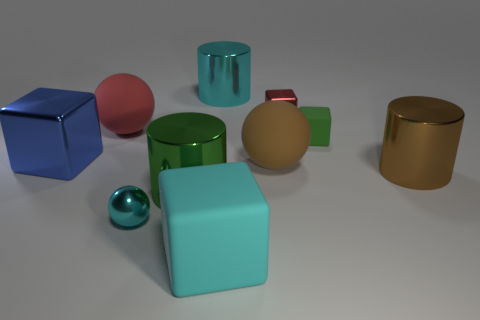Subtract all tiny metallic blocks. How many blocks are left? 3 Subtract all brown cylinders. How many cylinders are left? 2 Subtract 2 cylinders. How many cylinders are left? 1 Subtract all blue spheres. Subtract all green blocks. How many spheres are left? 3 Subtract all gray balls. How many green cylinders are left? 1 Subtract all yellow rubber cylinders. Subtract all cyan metallic objects. How many objects are left? 8 Add 8 blue objects. How many blue objects are left? 9 Add 8 big green rubber blocks. How many big green rubber blocks exist? 8 Subtract 1 green cylinders. How many objects are left? 9 Subtract all cylinders. How many objects are left? 7 